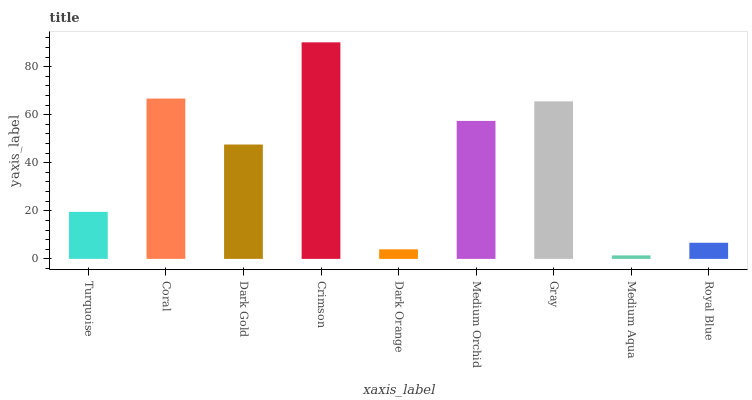Is Medium Aqua the minimum?
Answer yes or no. Yes. Is Crimson the maximum?
Answer yes or no. Yes. Is Coral the minimum?
Answer yes or no. No. Is Coral the maximum?
Answer yes or no. No. Is Coral greater than Turquoise?
Answer yes or no. Yes. Is Turquoise less than Coral?
Answer yes or no. Yes. Is Turquoise greater than Coral?
Answer yes or no. No. Is Coral less than Turquoise?
Answer yes or no. No. Is Dark Gold the high median?
Answer yes or no. Yes. Is Dark Gold the low median?
Answer yes or no. Yes. Is Medium Aqua the high median?
Answer yes or no. No. Is Dark Orange the low median?
Answer yes or no. No. 